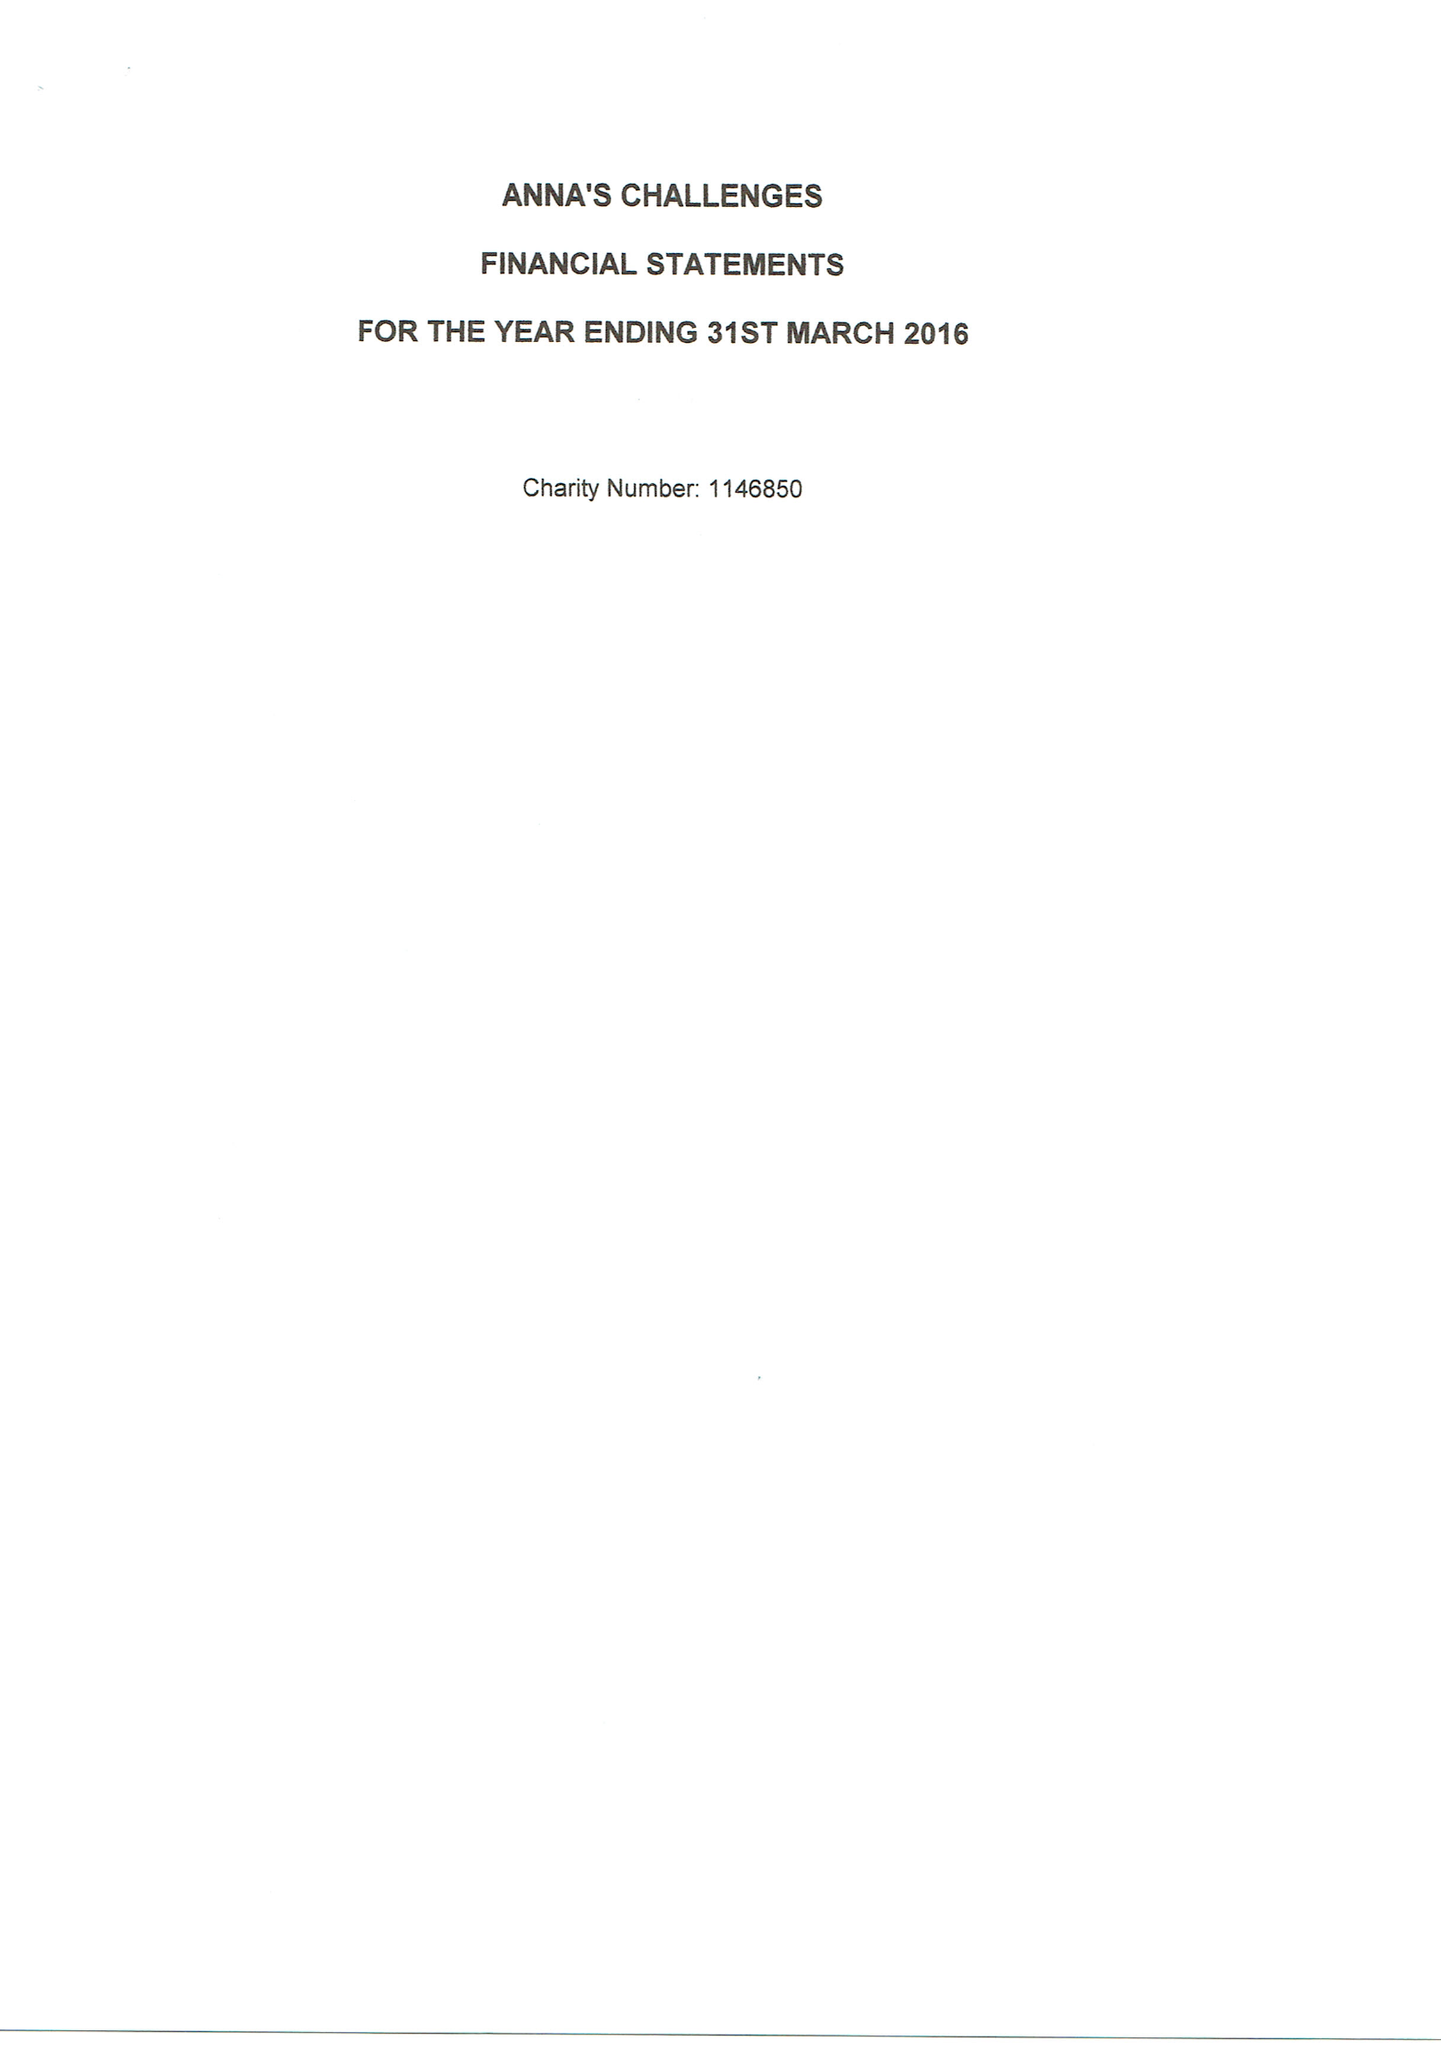What is the value for the spending_annually_in_british_pounds?
Answer the question using a single word or phrase. 30123.00 